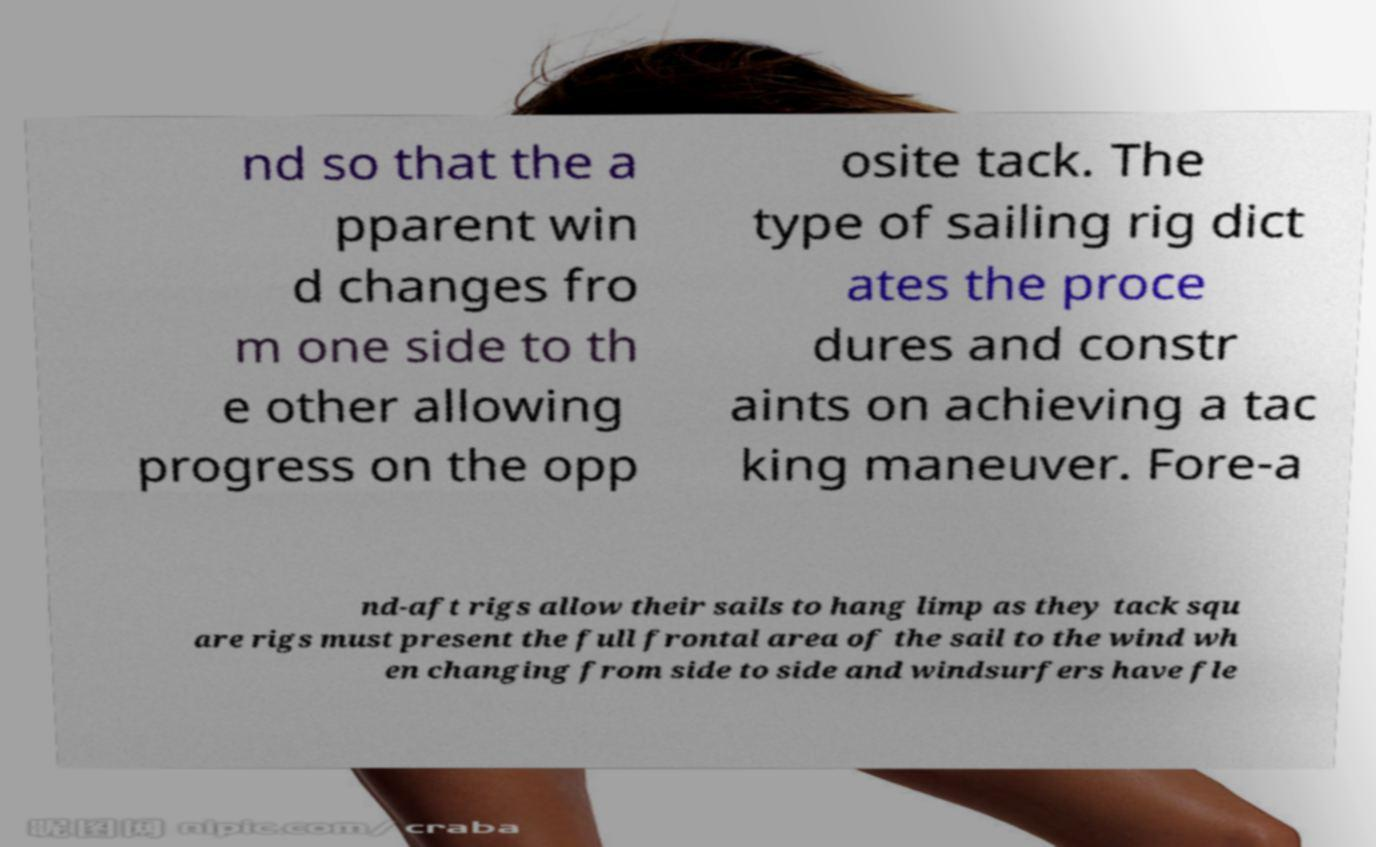Could you extract and type out the text from this image? nd so that the a pparent win d changes fro m one side to th e other allowing progress on the opp osite tack. The type of sailing rig dict ates the proce dures and constr aints on achieving a tac king maneuver. Fore-a nd-aft rigs allow their sails to hang limp as they tack squ are rigs must present the full frontal area of the sail to the wind wh en changing from side to side and windsurfers have fle 